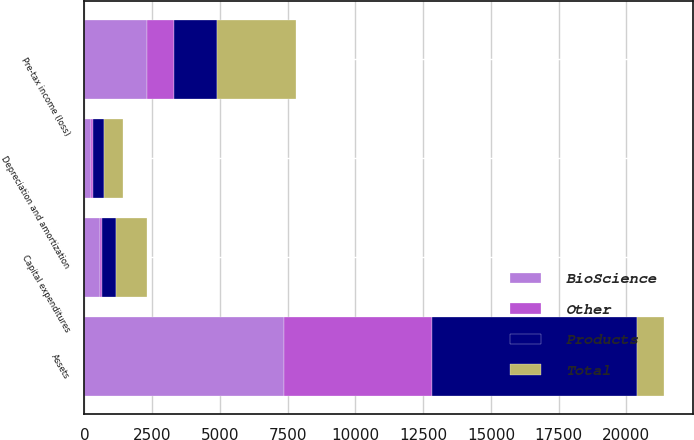<chart> <loc_0><loc_0><loc_500><loc_500><stacked_bar_chart><ecel><fcel>Depreciation and amortization<fcel>Pre-tax income (loss)<fcel>Assets<fcel>Capital expenditures<nl><fcel>BioScience<fcel>243<fcel>2309<fcel>7380<fcel>570<nl><fcel>Products<fcel>385<fcel>1592<fcel>7568<fcel>495<nl><fcel>Other<fcel>84<fcel>1012<fcel>5442<fcel>96<nl><fcel>Total<fcel>712<fcel>2889<fcel>1012<fcel>1161<nl></chart> 